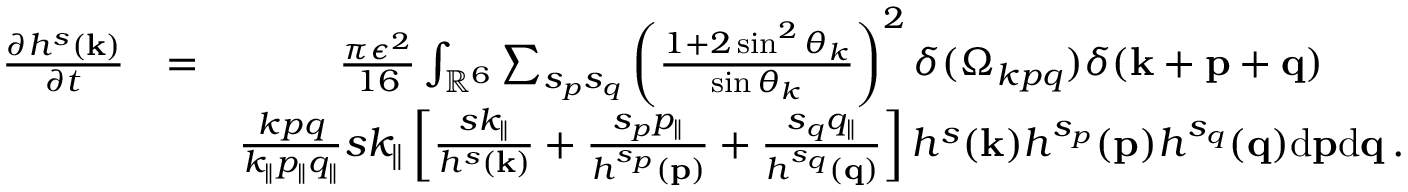<formula> <loc_0><loc_0><loc_500><loc_500>\begin{array} { r l r } { \frac { \partial h ^ { s } ( { k } ) } { \partial t } } & { = } & { \frac { \pi \epsilon ^ { 2 } } { 1 6 } \int _ { { \mathbb { R } } ^ { 6 } } \sum _ { s _ { p } s _ { q } } \left ( \frac { 1 + 2 \sin ^ { 2 } \theta _ { k } } { \sin \theta _ { k } } \right ) ^ { 2 } \delta ( \Omega _ { k p q } ) \delta ( { k } + { p } + { q } ) \quad } \\ & { \frac { k p q } { k _ { \| } p _ { \| } q _ { \| } } s k _ { \| } \left [ \frac { s k _ { \| } } { h ^ { s } ( { k } ) } + \frac { s _ { p } p _ { \| } } { h ^ { s _ { p } } ( { p } ) } + \frac { s _ { q } q _ { \| } } { h ^ { s _ { q } } ( { q } ) } \right ] h ^ { s } ( { k } ) h ^ { s _ { p } } ( { p } ) h ^ { s _ { q } } ( { q } ) d { p } d { q } \, . } \end{array}</formula> 